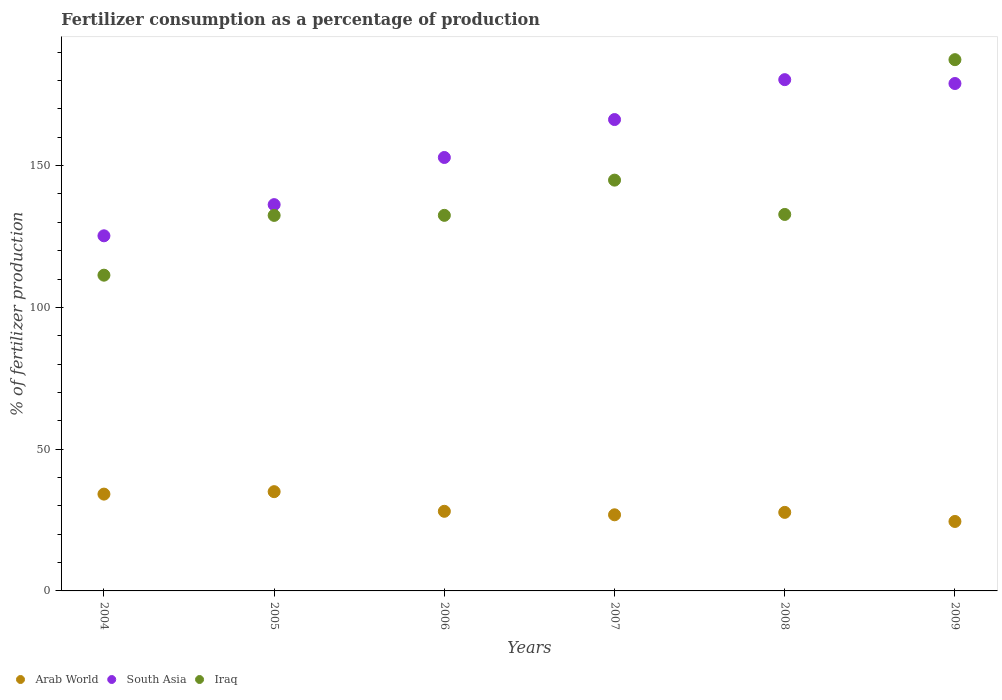How many different coloured dotlines are there?
Offer a terse response. 3. Is the number of dotlines equal to the number of legend labels?
Provide a short and direct response. Yes. What is the percentage of fertilizers consumed in South Asia in 2008?
Your answer should be compact. 180.31. Across all years, what is the maximum percentage of fertilizers consumed in Arab World?
Provide a short and direct response. 35. Across all years, what is the minimum percentage of fertilizers consumed in Iraq?
Your answer should be very brief. 111.35. In which year was the percentage of fertilizers consumed in South Asia maximum?
Your answer should be compact. 2008. In which year was the percentage of fertilizers consumed in South Asia minimum?
Provide a succinct answer. 2004. What is the total percentage of fertilizers consumed in Arab World in the graph?
Provide a succinct answer. 176.27. What is the difference between the percentage of fertilizers consumed in Iraq in 2005 and that in 2006?
Provide a succinct answer. -0.02. What is the difference between the percentage of fertilizers consumed in Iraq in 2005 and the percentage of fertilizers consumed in South Asia in 2009?
Keep it short and to the point. -46.51. What is the average percentage of fertilizers consumed in Arab World per year?
Your answer should be very brief. 29.38. In the year 2007, what is the difference between the percentage of fertilizers consumed in Iraq and percentage of fertilizers consumed in Arab World?
Offer a terse response. 118.03. In how many years, is the percentage of fertilizers consumed in Iraq greater than 150 %?
Your answer should be very brief. 1. What is the ratio of the percentage of fertilizers consumed in South Asia in 2005 to that in 2007?
Provide a short and direct response. 0.82. Is the difference between the percentage of fertilizers consumed in Iraq in 2007 and 2009 greater than the difference between the percentage of fertilizers consumed in Arab World in 2007 and 2009?
Keep it short and to the point. No. What is the difference between the highest and the second highest percentage of fertilizers consumed in Iraq?
Offer a terse response. 42.48. What is the difference between the highest and the lowest percentage of fertilizers consumed in Arab World?
Offer a very short reply. 10.51. Is it the case that in every year, the sum of the percentage of fertilizers consumed in South Asia and percentage of fertilizers consumed in Arab World  is greater than the percentage of fertilizers consumed in Iraq?
Ensure brevity in your answer.  Yes. How many dotlines are there?
Keep it short and to the point. 3. How many years are there in the graph?
Give a very brief answer. 6. What is the difference between two consecutive major ticks on the Y-axis?
Offer a very short reply. 50. Are the values on the major ticks of Y-axis written in scientific E-notation?
Your answer should be compact. No. Does the graph contain any zero values?
Offer a very short reply. No. Does the graph contain grids?
Your answer should be very brief. No. How are the legend labels stacked?
Ensure brevity in your answer.  Horizontal. What is the title of the graph?
Give a very brief answer. Fertilizer consumption as a percentage of production. Does "Turks and Caicos Islands" appear as one of the legend labels in the graph?
Your response must be concise. No. What is the label or title of the Y-axis?
Your answer should be very brief. % of fertilizer production. What is the % of fertilizer production in Arab World in 2004?
Your answer should be very brief. 34.14. What is the % of fertilizer production in South Asia in 2004?
Ensure brevity in your answer.  125.24. What is the % of fertilizer production in Iraq in 2004?
Make the answer very short. 111.35. What is the % of fertilizer production in Arab World in 2005?
Provide a succinct answer. 35. What is the % of fertilizer production in South Asia in 2005?
Provide a succinct answer. 136.23. What is the % of fertilizer production of Iraq in 2005?
Make the answer very short. 132.44. What is the % of fertilizer production in Arab World in 2006?
Your answer should be very brief. 28.08. What is the % of fertilizer production in South Asia in 2006?
Your response must be concise. 152.86. What is the % of fertilizer production of Iraq in 2006?
Provide a succinct answer. 132.45. What is the % of fertilizer production in Arab World in 2007?
Provide a succinct answer. 26.85. What is the % of fertilizer production in South Asia in 2007?
Your answer should be compact. 166.24. What is the % of fertilizer production in Iraq in 2007?
Your response must be concise. 144.87. What is the % of fertilizer production of Arab World in 2008?
Give a very brief answer. 27.7. What is the % of fertilizer production in South Asia in 2008?
Ensure brevity in your answer.  180.31. What is the % of fertilizer production in Iraq in 2008?
Ensure brevity in your answer.  132.77. What is the % of fertilizer production in Arab World in 2009?
Provide a short and direct response. 24.5. What is the % of fertilizer production in South Asia in 2009?
Offer a terse response. 178.95. What is the % of fertilizer production of Iraq in 2009?
Keep it short and to the point. 187.36. Across all years, what is the maximum % of fertilizer production in Arab World?
Keep it short and to the point. 35. Across all years, what is the maximum % of fertilizer production in South Asia?
Provide a short and direct response. 180.31. Across all years, what is the maximum % of fertilizer production of Iraq?
Keep it short and to the point. 187.36. Across all years, what is the minimum % of fertilizer production of Arab World?
Your response must be concise. 24.5. Across all years, what is the minimum % of fertilizer production of South Asia?
Your response must be concise. 125.24. Across all years, what is the minimum % of fertilizer production in Iraq?
Give a very brief answer. 111.35. What is the total % of fertilizer production in Arab World in the graph?
Your answer should be very brief. 176.27. What is the total % of fertilizer production of South Asia in the graph?
Ensure brevity in your answer.  939.83. What is the total % of fertilizer production in Iraq in the graph?
Your response must be concise. 841.25. What is the difference between the % of fertilizer production of Arab World in 2004 and that in 2005?
Provide a succinct answer. -0.86. What is the difference between the % of fertilizer production of South Asia in 2004 and that in 2005?
Your response must be concise. -10.99. What is the difference between the % of fertilizer production of Iraq in 2004 and that in 2005?
Give a very brief answer. -21.08. What is the difference between the % of fertilizer production of Arab World in 2004 and that in 2006?
Your answer should be very brief. 6.06. What is the difference between the % of fertilizer production of South Asia in 2004 and that in 2006?
Make the answer very short. -27.62. What is the difference between the % of fertilizer production of Iraq in 2004 and that in 2006?
Your response must be concise. -21.1. What is the difference between the % of fertilizer production in Arab World in 2004 and that in 2007?
Your response must be concise. 7.3. What is the difference between the % of fertilizer production in South Asia in 2004 and that in 2007?
Offer a very short reply. -41. What is the difference between the % of fertilizer production of Iraq in 2004 and that in 2007?
Provide a short and direct response. -33.52. What is the difference between the % of fertilizer production of Arab World in 2004 and that in 2008?
Provide a succinct answer. 6.44. What is the difference between the % of fertilizer production of South Asia in 2004 and that in 2008?
Your response must be concise. -55.07. What is the difference between the % of fertilizer production in Iraq in 2004 and that in 2008?
Offer a very short reply. -21.42. What is the difference between the % of fertilizer production of Arab World in 2004 and that in 2009?
Your answer should be compact. 9.65. What is the difference between the % of fertilizer production in South Asia in 2004 and that in 2009?
Provide a succinct answer. -53.71. What is the difference between the % of fertilizer production in Iraq in 2004 and that in 2009?
Ensure brevity in your answer.  -76.01. What is the difference between the % of fertilizer production of Arab World in 2005 and that in 2006?
Offer a very short reply. 6.92. What is the difference between the % of fertilizer production in South Asia in 2005 and that in 2006?
Provide a short and direct response. -16.63. What is the difference between the % of fertilizer production in Iraq in 2005 and that in 2006?
Make the answer very short. -0.02. What is the difference between the % of fertilizer production in Arab World in 2005 and that in 2007?
Make the answer very short. 8.16. What is the difference between the % of fertilizer production of South Asia in 2005 and that in 2007?
Make the answer very short. -30. What is the difference between the % of fertilizer production of Iraq in 2005 and that in 2007?
Offer a terse response. -12.44. What is the difference between the % of fertilizer production in Arab World in 2005 and that in 2008?
Your answer should be very brief. 7.3. What is the difference between the % of fertilizer production of South Asia in 2005 and that in 2008?
Provide a short and direct response. -44.07. What is the difference between the % of fertilizer production in Iraq in 2005 and that in 2008?
Your answer should be compact. -0.34. What is the difference between the % of fertilizer production of Arab World in 2005 and that in 2009?
Offer a very short reply. 10.51. What is the difference between the % of fertilizer production in South Asia in 2005 and that in 2009?
Provide a short and direct response. -42.71. What is the difference between the % of fertilizer production in Iraq in 2005 and that in 2009?
Your response must be concise. -54.92. What is the difference between the % of fertilizer production of Arab World in 2006 and that in 2007?
Provide a succinct answer. 1.23. What is the difference between the % of fertilizer production of South Asia in 2006 and that in 2007?
Offer a terse response. -13.38. What is the difference between the % of fertilizer production of Iraq in 2006 and that in 2007?
Make the answer very short. -12.42. What is the difference between the % of fertilizer production of Arab World in 2006 and that in 2008?
Offer a very short reply. 0.38. What is the difference between the % of fertilizer production in South Asia in 2006 and that in 2008?
Offer a very short reply. -27.45. What is the difference between the % of fertilizer production in Iraq in 2006 and that in 2008?
Ensure brevity in your answer.  -0.32. What is the difference between the % of fertilizer production of Arab World in 2006 and that in 2009?
Your answer should be compact. 3.58. What is the difference between the % of fertilizer production in South Asia in 2006 and that in 2009?
Your response must be concise. -26.09. What is the difference between the % of fertilizer production of Iraq in 2006 and that in 2009?
Keep it short and to the point. -54.9. What is the difference between the % of fertilizer production in Arab World in 2007 and that in 2008?
Your answer should be compact. -0.85. What is the difference between the % of fertilizer production in South Asia in 2007 and that in 2008?
Your answer should be compact. -14.07. What is the difference between the % of fertilizer production of Iraq in 2007 and that in 2008?
Keep it short and to the point. 12.1. What is the difference between the % of fertilizer production of Arab World in 2007 and that in 2009?
Provide a short and direct response. 2.35. What is the difference between the % of fertilizer production in South Asia in 2007 and that in 2009?
Offer a very short reply. -12.71. What is the difference between the % of fertilizer production of Iraq in 2007 and that in 2009?
Give a very brief answer. -42.48. What is the difference between the % of fertilizer production in Arab World in 2008 and that in 2009?
Your response must be concise. 3.2. What is the difference between the % of fertilizer production of South Asia in 2008 and that in 2009?
Offer a terse response. 1.36. What is the difference between the % of fertilizer production of Iraq in 2008 and that in 2009?
Ensure brevity in your answer.  -54.59. What is the difference between the % of fertilizer production in Arab World in 2004 and the % of fertilizer production in South Asia in 2005?
Give a very brief answer. -102.09. What is the difference between the % of fertilizer production of Arab World in 2004 and the % of fertilizer production of Iraq in 2005?
Make the answer very short. -98.29. What is the difference between the % of fertilizer production in South Asia in 2004 and the % of fertilizer production in Iraq in 2005?
Provide a short and direct response. -7.19. What is the difference between the % of fertilizer production of Arab World in 2004 and the % of fertilizer production of South Asia in 2006?
Give a very brief answer. -118.72. What is the difference between the % of fertilizer production of Arab World in 2004 and the % of fertilizer production of Iraq in 2006?
Make the answer very short. -98.31. What is the difference between the % of fertilizer production in South Asia in 2004 and the % of fertilizer production in Iraq in 2006?
Provide a succinct answer. -7.21. What is the difference between the % of fertilizer production in Arab World in 2004 and the % of fertilizer production in South Asia in 2007?
Your response must be concise. -132.1. What is the difference between the % of fertilizer production of Arab World in 2004 and the % of fertilizer production of Iraq in 2007?
Keep it short and to the point. -110.73. What is the difference between the % of fertilizer production in South Asia in 2004 and the % of fertilizer production in Iraq in 2007?
Provide a succinct answer. -19.63. What is the difference between the % of fertilizer production of Arab World in 2004 and the % of fertilizer production of South Asia in 2008?
Your response must be concise. -146.17. What is the difference between the % of fertilizer production of Arab World in 2004 and the % of fertilizer production of Iraq in 2008?
Your answer should be very brief. -98.63. What is the difference between the % of fertilizer production of South Asia in 2004 and the % of fertilizer production of Iraq in 2008?
Give a very brief answer. -7.53. What is the difference between the % of fertilizer production of Arab World in 2004 and the % of fertilizer production of South Asia in 2009?
Your answer should be compact. -144.81. What is the difference between the % of fertilizer production in Arab World in 2004 and the % of fertilizer production in Iraq in 2009?
Provide a short and direct response. -153.22. What is the difference between the % of fertilizer production of South Asia in 2004 and the % of fertilizer production of Iraq in 2009?
Keep it short and to the point. -62.12. What is the difference between the % of fertilizer production of Arab World in 2005 and the % of fertilizer production of South Asia in 2006?
Give a very brief answer. -117.86. What is the difference between the % of fertilizer production of Arab World in 2005 and the % of fertilizer production of Iraq in 2006?
Offer a very short reply. -97.45. What is the difference between the % of fertilizer production of South Asia in 2005 and the % of fertilizer production of Iraq in 2006?
Make the answer very short. 3.78. What is the difference between the % of fertilizer production of Arab World in 2005 and the % of fertilizer production of South Asia in 2007?
Your answer should be compact. -131.23. What is the difference between the % of fertilizer production in Arab World in 2005 and the % of fertilizer production in Iraq in 2007?
Keep it short and to the point. -109.87. What is the difference between the % of fertilizer production of South Asia in 2005 and the % of fertilizer production of Iraq in 2007?
Keep it short and to the point. -8.64. What is the difference between the % of fertilizer production of Arab World in 2005 and the % of fertilizer production of South Asia in 2008?
Ensure brevity in your answer.  -145.3. What is the difference between the % of fertilizer production of Arab World in 2005 and the % of fertilizer production of Iraq in 2008?
Your answer should be compact. -97.77. What is the difference between the % of fertilizer production of South Asia in 2005 and the % of fertilizer production of Iraq in 2008?
Your response must be concise. 3.46. What is the difference between the % of fertilizer production of Arab World in 2005 and the % of fertilizer production of South Asia in 2009?
Provide a short and direct response. -143.95. What is the difference between the % of fertilizer production in Arab World in 2005 and the % of fertilizer production in Iraq in 2009?
Your answer should be very brief. -152.35. What is the difference between the % of fertilizer production in South Asia in 2005 and the % of fertilizer production in Iraq in 2009?
Your response must be concise. -51.12. What is the difference between the % of fertilizer production in Arab World in 2006 and the % of fertilizer production in South Asia in 2007?
Provide a short and direct response. -138.16. What is the difference between the % of fertilizer production of Arab World in 2006 and the % of fertilizer production of Iraq in 2007?
Make the answer very short. -116.79. What is the difference between the % of fertilizer production in South Asia in 2006 and the % of fertilizer production in Iraq in 2007?
Give a very brief answer. 7.99. What is the difference between the % of fertilizer production of Arab World in 2006 and the % of fertilizer production of South Asia in 2008?
Provide a short and direct response. -152.23. What is the difference between the % of fertilizer production of Arab World in 2006 and the % of fertilizer production of Iraq in 2008?
Your response must be concise. -104.69. What is the difference between the % of fertilizer production of South Asia in 2006 and the % of fertilizer production of Iraq in 2008?
Provide a short and direct response. 20.09. What is the difference between the % of fertilizer production in Arab World in 2006 and the % of fertilizer production in South Asia in 2009?
Your answer should be very brief. -150.87. What is the difference between the % of fertilizer production of Arab World in 2006 and the % of fertilizer production of Iraq in 2009?
Your answer should be very brief. -159.28. What is the difference between the % of fertilizer production in South Asia in 2006 and the % of fertilizer production in Iraq in 2009?
Keep it short and to the point. -34.5. What is the difference between the % of fertilizer production in Arab World in 2007 and the % of fertilizer production in South Asia in 2008?
Make the answer very short. -153.46. What is the difference between the % of fertilizer production of Arab World in 2007 and the % of fertilizer production of Iraq in 2008?
Offer a terse response. -105.93. What is the difference between the % of fertilizer production of South Asia in 2007 and the % of fertilizer production of Iraq in 2008?
Offer a terse response. 33.47. What is the difference between the % of fertilizer production in Arab World in 2007 and the % of fertilizer production in South Asia in 2009?
Provide a succinct answer. -152.1. What is the difference between the % of fertilizer production in Arab World in 2007 and the % of fertilizer production in Iraq in 2009?
Your answer should be compact. -160.51. What is the difference between the % of fertilizer production of South Asia in 2007 and the % of fertilizer production of Iraq in 2009?
Keep it short and to the point. -21.12. What is the difference between the % of fertilizer production in Arab World in 2008 and the % of fertilizer production in South Asia in 2009?
Provide a succinct answer. -151.25. What is the difference between the % of fertilizer production of Arab World in 2008 and the % of fertilizer production of Iraq in 2009?
Keep it short and to the point. -159.66. What is the difference between the % of fertilizer production in South Asia in 2008 and the % of fertilizer production in Iraq in 2009?
Offer a terse response. -7.05. What is the average % of fertilizer production of Arab World per year?
Provide a succinct answer. 29.38. What is the average % of fertilizer production in South Asia per year?
Offer a terse response. 156.64. What is the average % of fertilizer production in Iraq per year?
Keep it short and to the point. 140.21. In the year 2004, what is the difference between the % of fertilizer production in Arab World and % of fertilizer production in South Asia?
Provide a short and direct response. -91.1. In the year 2004, what is the difference between the % of fertilizer production of Arab World and % of fertilizer production of Iraq?
Provide a short and direct response. -77.21. In the year 2004, what is the difference between the % of fertilizer production in South Asia and % of fertilizer production in Iraq?
Your answer should be compact. 13.89. In the year 2005, what is the difference between the % of fertilizer production in Arab World and % of fertilizer production in South Asia?
Keep it short and to the point. -101.23. In the year 2005, what is the difference between the % of fertilizer production of Arab World and % of fertilizer production of Iraq?
Give a very brief answer. -97.43. In the year 2005, what is the difference between the % of fertilizer production in South Asia and % of fertilizer production in Iraq?
Offer a terse response. 3.8. In the year 2006, what is the difference between the % of fertilizer production of Arab World and % of fertilizer production of South Asia?
Make the answer very short. -124.78. In the year 2006, what is the difference between the % of fertilizer production of Arab World and % of fertilizer production of Iraq?
Offer a terse response. -104.37. In the year 2006, what is the difference between the % of fertilizer production of South Asia and % of fertilizer production of Iraq?
Your answer should be compact. 20.41. In the year 2007, what is the difference between the % of fertilizer production in Arab World and % of fertilizer production in South Asia?
Keep it short and to the point. -139.39. In the year 2007, what is the difference between the % of fertilizer production of Arab World and % of fertilizer production of Iraq?
Offer a terse response. -118.03. In the year 2007, what is the difference between the % of fertilizer production in South Asia and % of fertilizer production in Iraq?
Ensure brevity in your answer.  21.37. In the year 2008, what is the difference between the % of fertilizer production of Arab World and % of fertilizer production of South Asia?
Your response must be concise. -152.61. In the year 2008, what is the difference between the % of fertilizer production in Arab World and % of fertilizer production in Iraq?
Provide a succinct answer. -105.07. In the year 2008, what is the difference between the % of fertilizer production of South Asia and % of fertilizer production of Iraq?
Make the answer very short. 47.53. In the year 2009, what is the difference between the % of fertilizer production in Arab World and % of fertilizer production in South Asia?
Keep it short and to the point. -154.45. In the year 2009, what is the difference between the % of fertilizer production of Arab World and % of fertilizer production of Iraq?
Your answer should be very brief. -162.86. In the year 2009, what is the difference between the % of fertilizer production of South Asia and % of fertilizer production of Iraq?
Give a very brief answer. -8.41. What is the ratio of the % of fertilizer production in Arab World in 2004 to that in 2005?
Give a very brief answer. 0.98. What is the ratio of the % of fertilizer production in South Asia in 2004 to that in 2005?
Give a very brief answer. 0.92. What is the ratio of the % of fertilizer production in Iraq in 2004 to that in 2005?
Give a very brief answer. 0.84. What is the ratio of the % of fertilizer production of Arab World in 2004 to that in 2006?
Provide a succinct answer. 1.22. What is the ratio of the % of fertilizer production in South Asia in 2004 to that in 2006?
Offer a terse response. 0.82. What is the ratio of the % of fertilizer production in Iraq in 2004 to that in 2006?
Your response must be concise. 0.84. What is the ratio of the % of fertilizer production of Arab World in 2004 to that in 2007?
Give a very brief answer. 1.27. What is the ratio of the % of fertilizer production in South Asia in 2004 to that in 2007?
Your response must be concise. 0.75. What is the ratio of the % of fertilizer production of Iraq in 2004 to that in 2007?
Ensure brevity in your answer.  0.77. What is the ratio of the % of fertilizer production of Arab World in 2004 to that in 2008?
Give a very brief answer. 1.23. What is the ratio of the % of fertilizer production in South Asia in 2004 to that in 2008?
Your answer should be compact. 0.69. What is the ratio of the % of fertilizer production of Iraq in 2004 to that in 2008?
Your response must be concise. 0.84. What is the ratio of the % of fertilizer production in Arab World in 2004 to that in 2009?
Give a very brief answer. 1.39. What is the ratio of the % of fertilizer production in South Asia in 2004 to that in 2009?
Provide a succinct answer. 0.7. What is the ratio of the % of fertilizer production in Iraq in 2004 to that in 2009?
Provide a succinct answer. 0.59. What is the ratio of the % of fertilizer production in Arab World in 2005 to that in 2006?
Offer a very short reply. 1.25. What is the ratio of the % of fertilizer production in South Asia in 2005 to that in 2006?
Provide a succinct answer. 0.89. What is the ratio of the % of fertilizer production in Arab World in 2005 to that in 2007?
Keep it short and to the point. 1.3. What is the ratio of the % of fertilizer production in South Asia in 2005 to that in 2007?
Offer a terse response. 0.82. What is the ratio of the % of fertilizer production of Iraq in 2005 to that in 2007?
Ensure brevity in your answer.  0.91. What is the ratio of the % of fertilizer production of Arab World in 2005 to that in 2008?
Offer a very short reply. 1.26. What is the ratio of the % of fertilizer production of South Asia in 2005 to that in 2008?
Give a very brief answer. 0.76. What is the ratio of the % of fertilizer production of Arab World in 2005 to that in 2009?
Provide a succinct answer. 1.43. What is the ratio of the % of fertilizer production of South Asia in 2005 to that in 2009?
Offer a very short reply. 0.76. What is the ratio of the % of fertilizer production of Iraq in 2005 to that in 2009?
Offer a very short reply. 0.71. What is the ratio of the % of fertilizer production of Arab World in 2006 to that in 2007?
Provide a succinct answer. 1.05. What is the ratio of the % of fertilizer production of South Asia in 2006 to that in 2007?
Give a very brief answer. 0.92. What is the ratio of the % of fertilizer production in Iraq in 2006 to that in 2007?
Your answer should be very brief. 0.91. What is the ratio of the % of fertilizer production in Arab World in 2006 to that in 2008?
Ensure brevity in your answer.  1.01. What is the ratio of the % of fertilizer production in South Asia in 2006 to that in 2008?
Ensure brevity in your answer.  0.85. What is the ratio of the % of fertilizer production of Iraq in 2006 to that in 2008?
Your response must be concise. 1. What is the ratio of the % of fertilizer production in Arab World in 2006 to that in 2009?
Provide a succinct answer. 1.15. What is the ratio of the % of fertilizer production of South Asia in 2006 to that in 2009?
Provide a succinct answer. 0.85. What is the ratio of the % of fertilizer production in Iraq in 2006 to that in 2009?
Offer a very short reply. 0.71. What is the ratio of the % of fertilizer production in Arab World in 2007 to that in 2008?
Give a very brief answer. 0.97. What is the ratio of the % of fertilizer production in South Asia in 2007 to that in 2008?
Your answer should be compact. 0.92. What is the ratio of the % of fertilizer production of Iraq in 2007 to that in 2008?
Your answer should be very brief. 1.09. What is the ratio of the % of fertilizer production of Arab World in 2007 to that in 2009?
Make the answer very short. 1.1. What is the ratio of the % of fertilizer production of South Asia in 2007 to that in 2009?
Your response must be concise. 0.93. What is the ratio of the % of fertilizer production of Iraq in 2007 to that in 2009?
Make the answer very short. 0.77. What is the ratio of the % of fertilizer production in Arab World in 2008 to that in 2009?
Provide a succinct answer. 1.13. What is the ratio of the % of fertilizer production of South Asia in 2008 to that in 2009?
Offer a terse response. 1.01. What is the ratio of the % of fertilizer production in Iraq in 2008 to that in 2009?
Your answer should be compact. 0.71. What is the difference between the highest and the second highest % of fertilizer production in Arab World?
Offer a very short reply. 0.86. What is the difference between the highest and the second highest % of fertilizer production of South Asia?
Make the answer very short. 1.36. What is the difference between the highest and the second highest % of fertilizer production of Iraq?
Your answer should be compact. 42.48. What is the difference between the highest and the lowest % of fertilizer production of Arab World?
Keep it short and to the point. 10.51. What is the difference between the highest and the lowest % of fertilizer production in South Asia?
Keep it short and to the point. 55.07. What is the difference between the highest and the lowest % of fertilizer production in Iraq?
Your response must be concise. 76.01. 